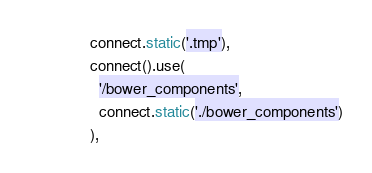Convert code to text. <code><loc_0><loc_0><loc_500><loc_500><_JavaScript_>              connect.static('.tmp'),
              connect().use(
                '/bower_components',
                connect.static('./bower_components')
              ),</code> 